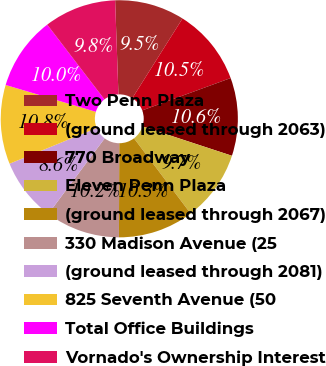Convert chart. <chart><loc_0><loc_0><loc_500><loc_500><pie_chart><fcel>Two Penn Plaza<fcel>(ground leased through 2063)<fcel>770 Broadway<fcel>Eleven Penn Plaza<fcel>(ground leased through 2067)<fcel>330 Madison Avenue (25<fcel>(ground leased through 2081)<fcel>825 Seventh Avenue (50<fcel>Total Office Buildings<fcel>Vornado's Ownership Interest<nl><fcel>9.51%<fcel>10.47%<fcel>10.63%<fcel>9.68%<fcel>10.32%<fcel>10.16%<fcel>8.61%<fcel>10.79%<fcel>10.0%<fcel>9.84%<nl></chart> 